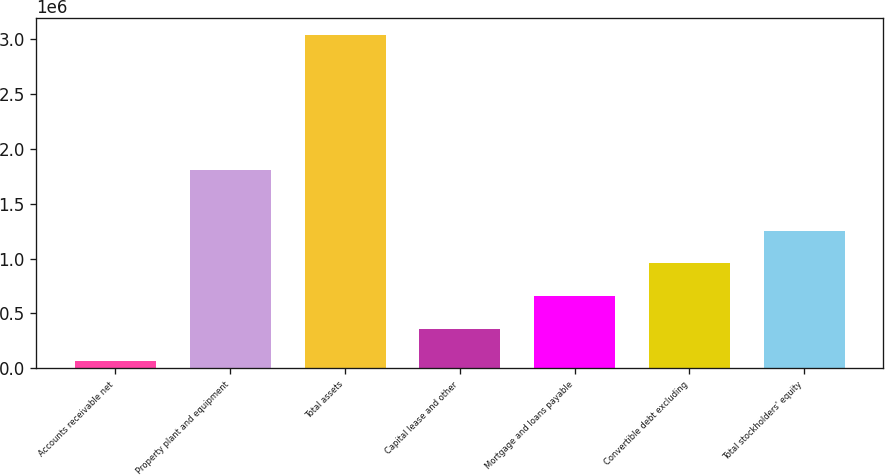Convert chart. <chart><loc_0><loc_0><loc_500><loc_500><bar_chart><fcel>Accounts receivable net<fcel>Property plant and equipment<fcel>Total assets<fcel>Capital lease and other<fcel>Mortgage and loans payable<fcel>Convertible debt excluding<fcel>Total stockholders' equity<nl><fcel>64767<fcel>1.80812e+06<fcel>3.03815e+06<fcel>362105<fcel>659444<fcel>956782<fcel>1.25412e+06<nl></chart> 